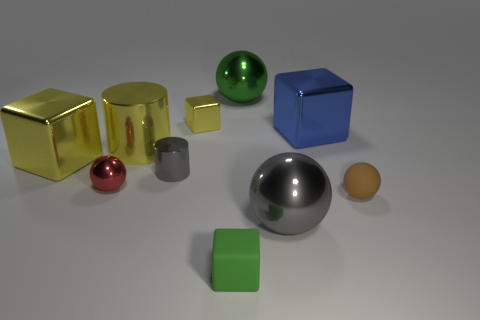Subtract all large yellow cubes. How many cubes are left? 3 Subtract all red spheres. How many yellow blocks are left? 2 Subtract 1 cubes. How many cubes are left? 3 Subtract all green balls. How many balls are left? 3 Subtract all blue spheres. Subtract all brown cylinders. How many spheres are left? 4 Subtract all blocks. How many objects are left? 6 Subtract all cubes. Subtract all large cyan cylinders. How many objects are left? 6 Add 1 yellow metallic cylinders. How many yellow metallic cylinders are left? 2 Add 5 metallic cylinders. How many metallic cylinders exist? 7 Subtract 1 red spheres. How many objects are left? 9 